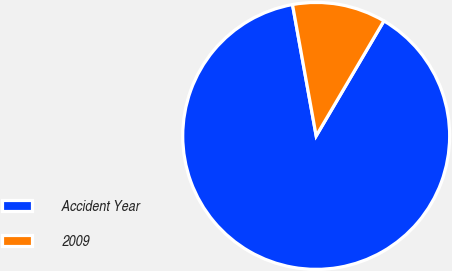Convert chart to OTSL. <chart><loc_0><loc_0><loc_500><loc_500><pie_chart><fcel>Accident Year<fcel>2009<nl><fcel>88.69%<fcel>11.31%<nl></chart> 